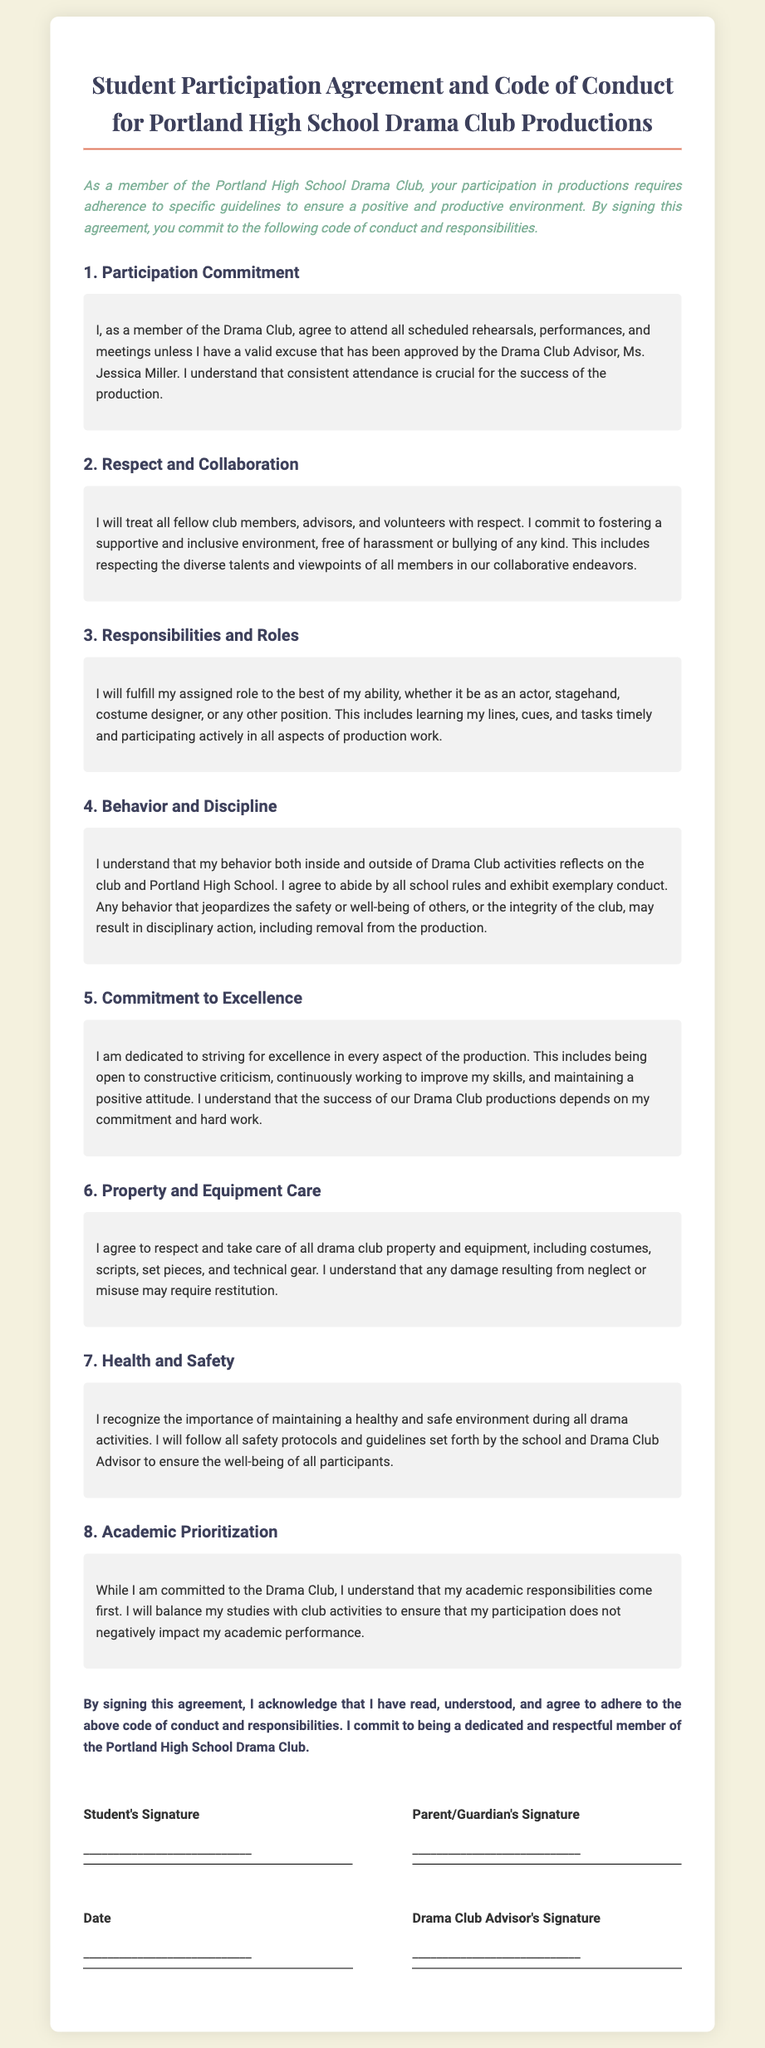What is the title of the document? The title is stated at the top of the document and highlights the purpose of the agreement.
Answer: Student Participation Agreement and Code of Conduct for Portland High School Drama Club Productions Who is the Drama Club Advisor? The Advisor's name is mentioned in the commitment section, which identifies the individual responsible for overseeing the club.
Answer: Ms. Jessica Miller How many sections are there in the agreement? The document contains various subsections, each outlining a key area of conduct or responsibility.
Answer: Eight What must a member do if they cannot attend a rehearsal? This is addressed in the participation commitment section regarding situations where attendance is not possible.
Answer: Valid excuse What is the focus of the "Commitment to Excellence" section? This section discusses the attitude and quality of effort expected from members regarding their roles in productions.
Answer: Striving for excellence What is required of members concerning academic performance? The document emphasizes that academic responsibilities should take priority over club activities.
Answer: Academic prioritization What may result from behavior that jeopardizes the club's integrity? The document outlines consequences related to conduct that negatively affects others or the drama club.
Answer: Disciplinary action What is a member’s responsibility regarding drama club property? This section specifically addresses how members should treat and maintain the club’s assets.
Answer: Respect and take care What should members do if they are given constructive criticism? This expectation is detailed in the commitment to excellence section of the document.
Answer: Be open to it 